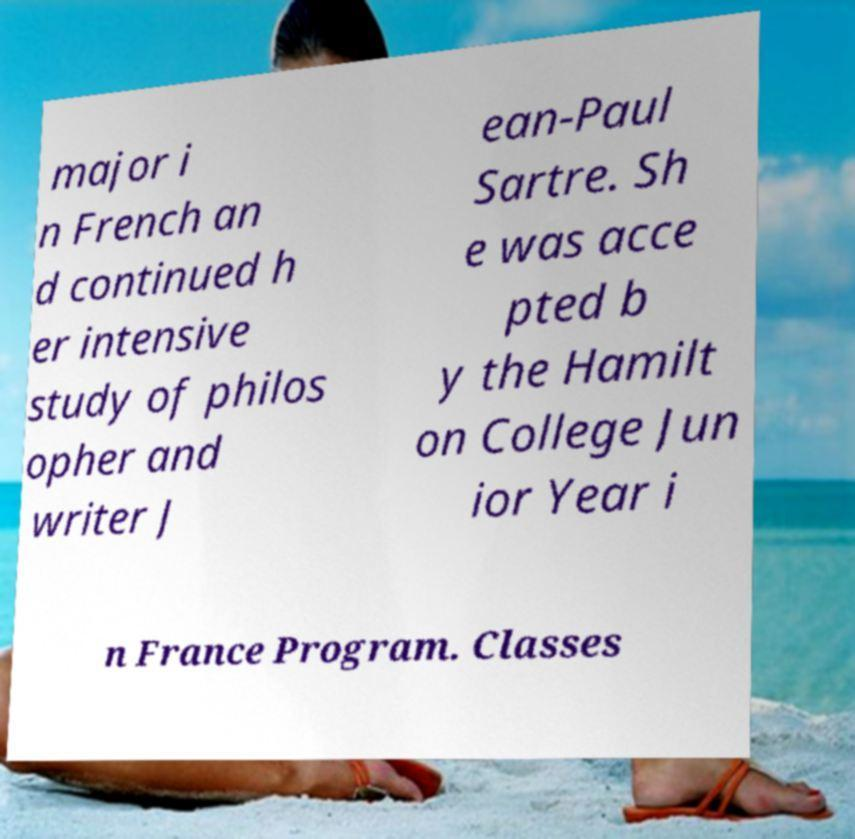What messages or text are displayed in this image? I need them in a readable, typed format. major i n French an d continued h er intensive study of philos opher and writer J ean-Paul Sartre. Sh e was acce pted b y the Hamilt on College Jun ior Year i n France Program. Classes 